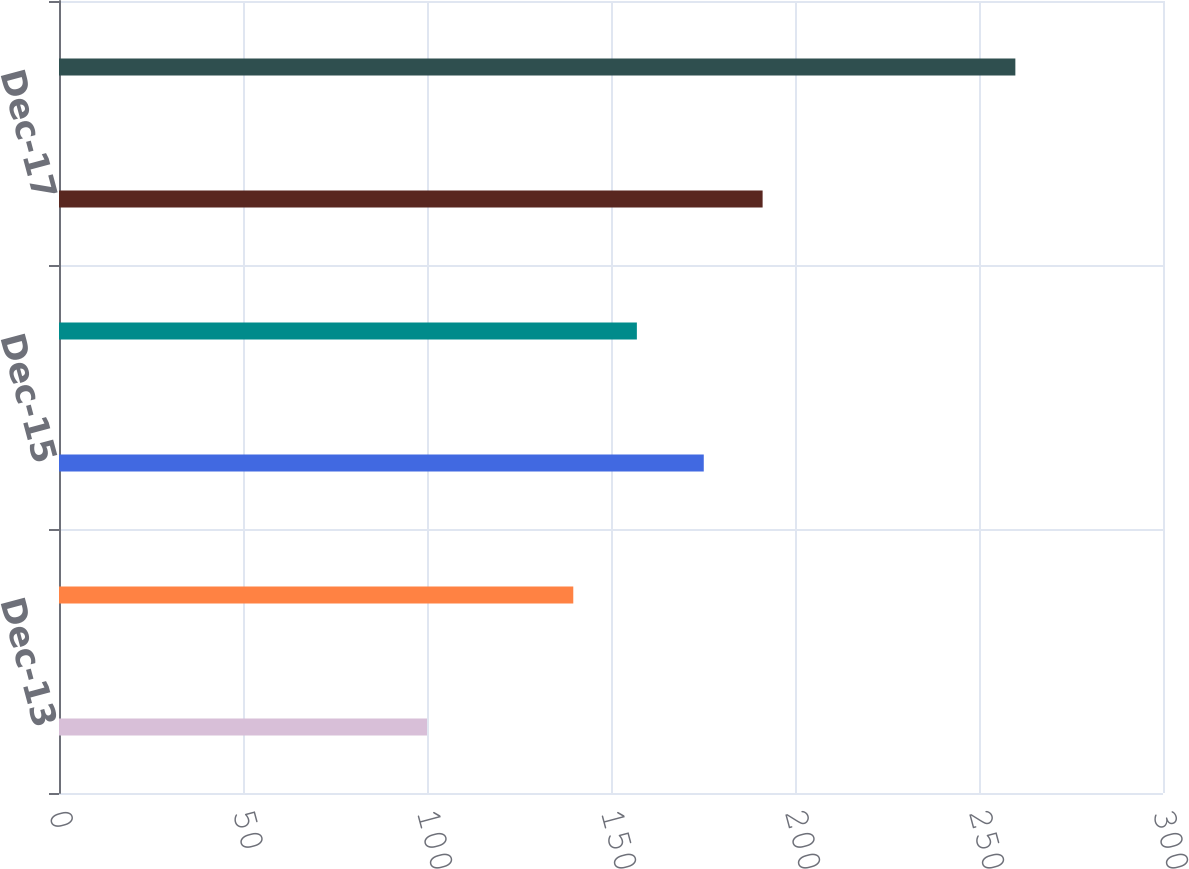Convert chart to OTSL. <chart><loc_0><loc_0><loc_500><loc_500><bar_chart><fcel>Dec-13<fcel>Dec-14<fcel>Dec-15<fcel>Dec-16<fcel>Dec-17<fcel>Dec-18<nl><fcel>100<fcel>139.75<fcel>175.21<fcel>157.03<fcel>191.2<fcel>259.88<nl></chart> 